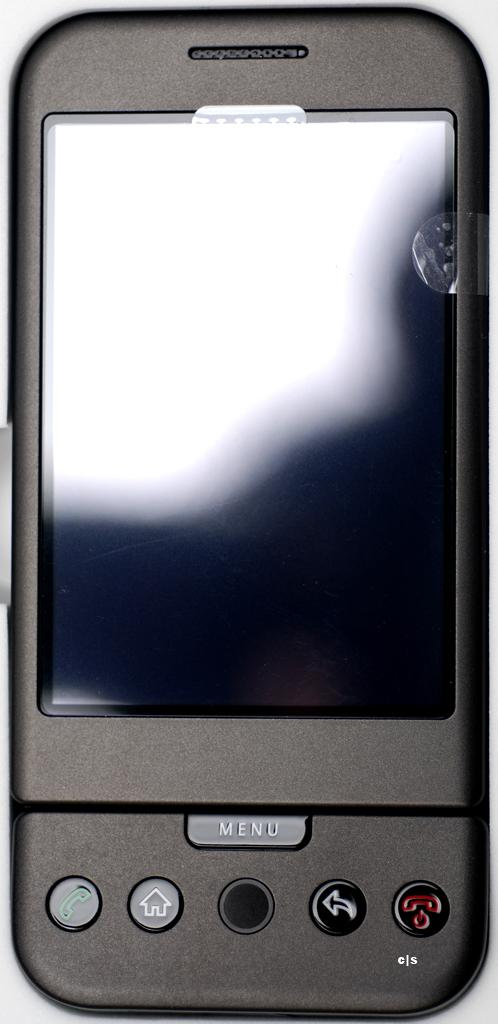<image>
Present a compact description of the photo's key features. A phone with a menu button on the bottom middle. 